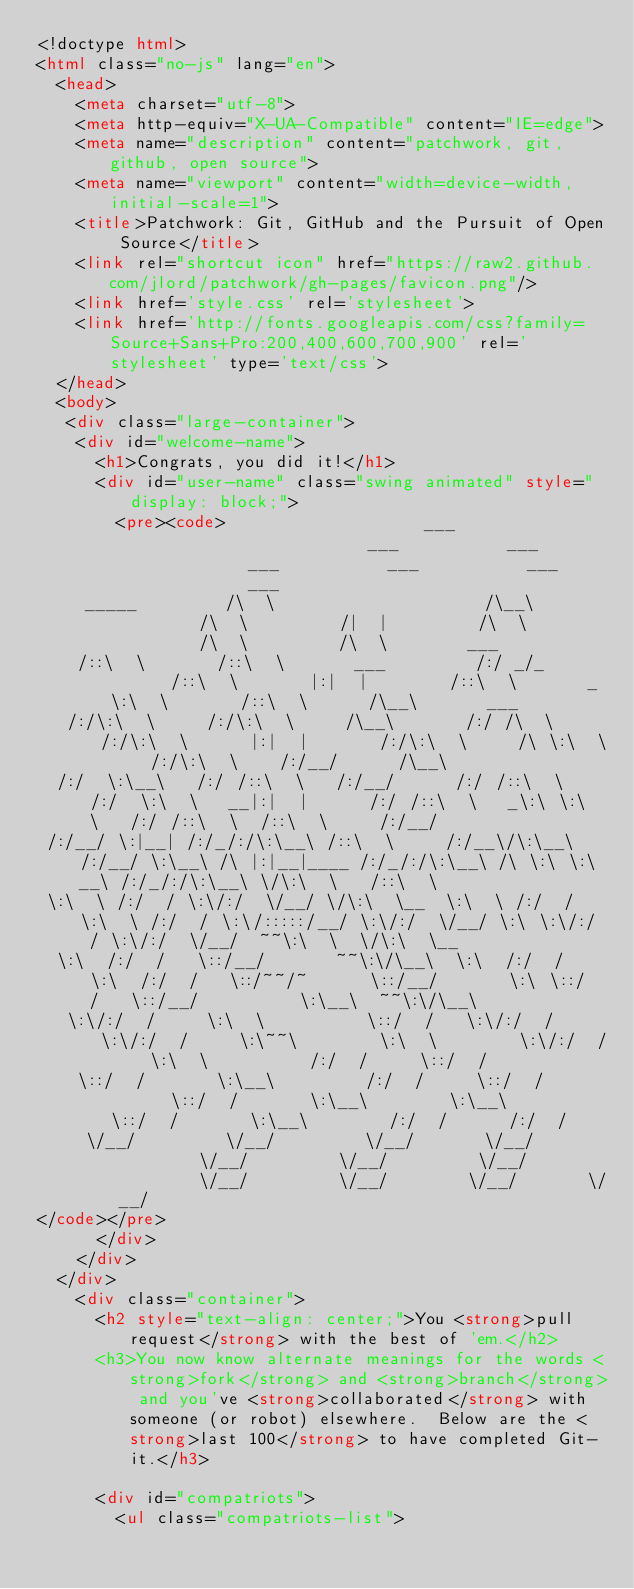Convert code to text. <code><loc_0><loc_0><loc_500><loc_500><_HTML_><!doctype html>
<html class="no-js" lang="en">
  <head>
    <meta charset="utf-8">
    <meta http-equiv="X-UA-Compatible" content="IE=edge">
    <meta name="description" content="patchwork, git, github, open source">
    <meta name="viewport" content="width=device-width, initial-scale=1">
    <title>Patchwork: Git, GitHub and the Pursuit of Open Source</title>
    <link rel="shortcut icon" href="https://raw2.github.com/jlord/patchwork/gh-pages/favicon.png"/>
    <link href='style.css' rel='stylesheet'>
    <link href='http://fonts.googleapis.com/css?family=Source+Sans+Pro:200,400,600,700,900' rel='stylesheet' type='text/css'>
  </head>
  <body>
   <div class="large-container">
    <div id="welcome-name">
      <h1>Congrats, you did it!</h1>
      <div id="user-name" class="swing animated" style="display: block;">
        <pre><code>                    ___                       ___           ___           ___           ___           ___           ___                            
     _____         /\  \                     /\__\         /\  \         /|  |         /\  \         /\  \         /\  \        ___                
    /::\  \       /::\  \       ___         /:/ _/_       /::\  \       |:|  |        /::\  \       _\:\  \       /::\  \      /\__\       ___     
   /:/\:\  \     /:/\:\  \     /\__\       /:/ /\  \     /:/\:\  \      |:|  |       /:/\:\  \     /\ \:\  \     /:/\:\  \    /:/__/      /\__\    
  /:/  \:\__\   /:/ /::\  \   /:/__/      /:/ /::\  \   /:/  \:\  \   __|:|  |      /:/ /::\  \   _\:\ \:\  \   /:/ /::\  \  /::\  \     /:/__/    
 /:/__/ \:|__| /:/_/:/\:\__\ /::\  \     /:/__\/\:\__\ /:/__/ \:\__\ /\ |:|__|____ /:/_/:/\:\__\ /\ \:\ \:\__\ /:/_/:/\:\__\ \/\:\  \   /::\  \    
 \:\  \ /:/  / \:\/:/  \/__/ \/\:\  \__  \:\  \ /:/  / \:\  \ /:/  / \:\/:::::/__/ \:\/:/  \/__/ \:\ \:\/:/  / \:\/:/  \/__/  ~~\:\  \  \/\:\  \__ 
  \:\  /:/  /   \::/__/       ~~\:\/\__\  \:\  /:/  /   \:\  /:/  /   \::/~~/~      \::/__/       \:\ \::/  /   \::/__/          \:\__\  ~~\:\/\__\
   \:\/:/  /     \:\  \          \::/  /   \:\/:/  /     \:\/:/  /     \:\~~\        \:\  \        \:\/:/  /     \:\  \          /:/  /     \::/  /
    \::/  /       \:\__\         /:/  /     \::/  /       \::/  /       \:\__\        \:\__\        \::/  /       \:\__\        /:/  /      /:/  / 
     \/__/         \/__/         \/__/       \/__/         \/__/         \/__/         \/__/         \/__/         \/__/        \/__/       \/__/  
</code></pre>
      </div>
    </div>
  </div>
    <div class="container">
      <h2 style="text-align: center;">You <strong>pull request</strong> with the best of 'em.</h2>
      <h3>You now know alternate meanings for the words <strong>fork</strong> and <strong>branch</strong> and you've <strong>collaborated</strong> with someone (or robot) elsewhere.  Below are the <strong>last 100</strong> to have completed Git-it.</h3>

      <div id="compatriots">
        <ul class="compatriots-list"></code> 